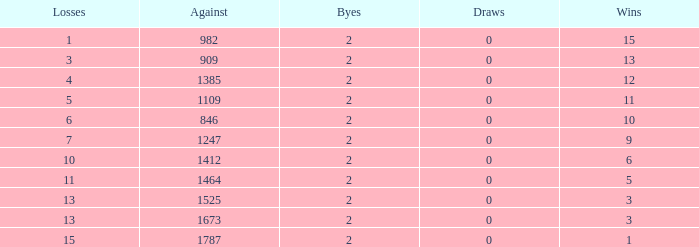What is the average number of Byes when there were less than 0 losses and were against 1247? None. 